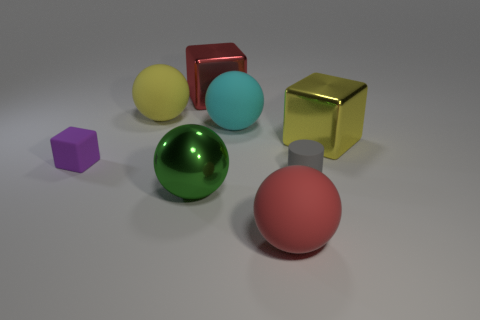What color is the block that is the same size as the gray rubber cylinder?
Ensure brevity in your answer.  Purple. There is a metal thing in front of the small block; is there a large green object left of it?
Your response must be concise. No. How many blocks are purple things or big red matte objects?
Provide a succinct answer. 1. There is a metallic cube to the right of the large object that is behind the big object that is left of the green metallic thing; what is its size?
Offer a terse response. Large. There is a purple cube; are there any cubes to the right of it?
Offer a terse response. Yes. What number of objects are tiny gray matte objects that are right of the big green metallic sphere or large brown rubber cylinders?
Provide a short and direct response. 1. There is a yellow thing that is the same material as the large cyan ball; what size is it?
Offer a terse response. Large. Is the size of the red metal block the same as the yellow object that is to the right of the gray cylinder?
Give a very brief answer. Yes. The block that is both right of the large yellow rubber object and to the left of the yellow block is what color?
Your answer should be very brief. Red. What number of objects are large matte objects on the right side of the cyan object or matte spheres that are behind the tiny block?
Provide a succinct answer. 3. 